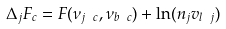<formula> <loc_0><loc_0><loc_500><loc_500>\Delta _ { j } F _ { c } = F ( \nu _ { j \ c } , \nu _ { b \ c } ) + \ln ( n _ { j } v _ { l \ j } )</formula> 